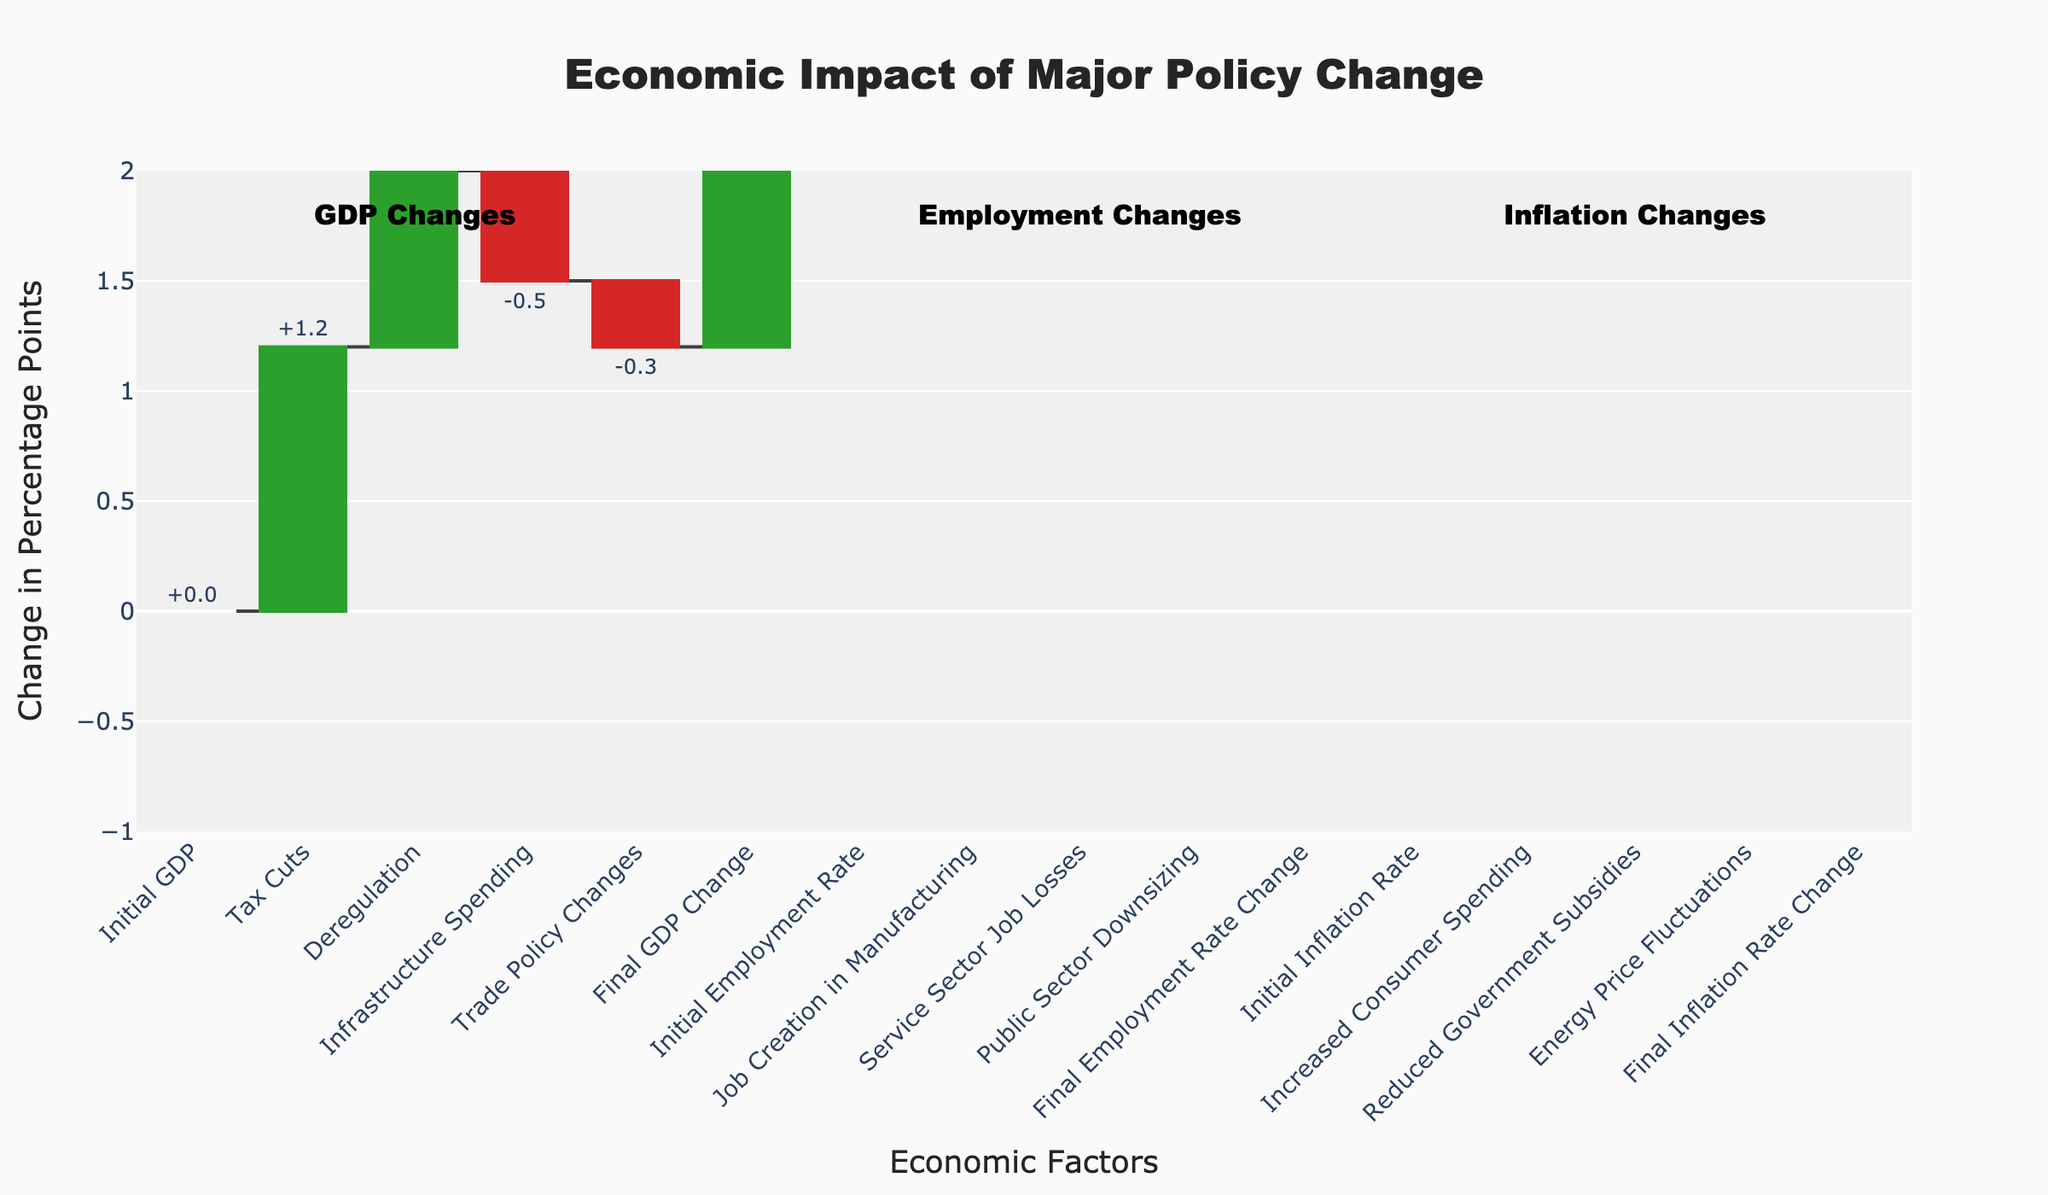Which economic factor had the largest positive impact on GDP? Tax Cuts had the largest positive impact on GDP, as indicated in the figure by contributing +1.2 percentage points.
Answer: Tax Cuts Which economic factor decreased GDP the most? Infrastructure Spending had the largest negative impact on GDP by -0.5 percentage points, which is shown as a downward step in the waterfall chart.
Answer: Infrastructure Spending What's the net change in GDP due to all illustrated factors? Summing all individual effects on GDP: 1.2 (Tax Cuts) + 0.8 (Deregulation) - 0.5 (Infrastructure Spending) - 0.3 (Trade Policy Changes) results in a total GDP change of 1.2 percentage points.
Answer: 1.2 What was the impact of Job Creation in Manufacturing on the Employment Rate? Job Creation in Manufacturing increased the Employment Rate by +0.7 percentage points, as seen by the upward step.
Answer: +0.7 How did Service Sector Job Losses and Public Sector Downsizing together affect the Employment Rate? Service Sector Job Losses decreased the Employment Rate by -0.4 and Public Sector Downsizing decreased it by -0.3. Together, their impact is -0.4 + (-0.3) = -0.7 percentage points.
Answer: -0.7 What is the final change in the Inflation Rate depicted in the chart? The final change in the Inflation Rate is +0.5 percentage points, which is listed as the last step in the Inflation section of the waterfall chart.
Answer: +0.5 Compare the effect of Increased Consumer Spending and Energy Price Fluctuations on Inflation Rate. Increased Consumer Spending increased the Inflation Rate by +0.4 percentage points, while Energy Price Fluctuations added +0.3 percentage points to inflation. Therefore, Increased Consumer Spending had a larger effect.
Answer: Increased Consumer Spending Which section of the economic factors shows the greatest variation: GDP, Employment Rate, or Inflation Rate? The GDP changes range from +1.2 to -0.5 (a range of 1.7), Employment Rate changes from +0.7 to -0.3 (a range of 1.0), and Inflation Rate from +0.4 to -0.2 (a range of 0.6). GDP has the greatest variation.
Answer: GDP What was the cumulative impact on GDP change before the effect of Trade Policy Changes? Summing the effects from the start up to before Trade Policy Changes: 0 (Initial GDP) + 1.2 (Tax Cuts) + 0.8 (Deregulation) - 0.5 (Infrastructure Spending) = 1.5 percentage points.
Answer: 1.5 